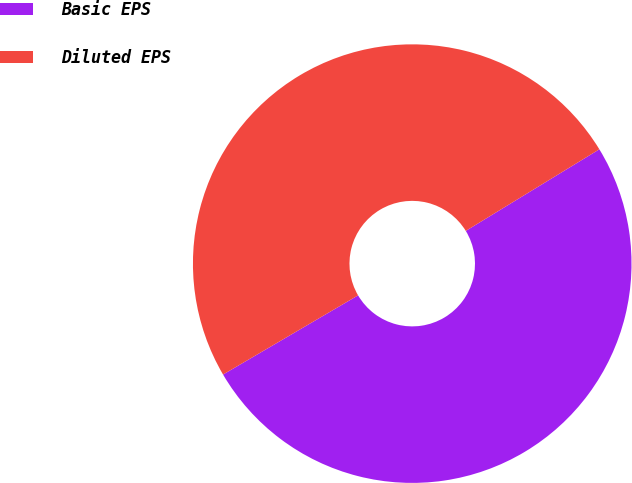Convert chart. <chart><loc_0><loc_0><loc_500><loc_500><pie_chart><fcel>Basic EPS<fcel>Diluted EPS<nl><fcel>50.29%<fcel>49.71%<nl></chart> 